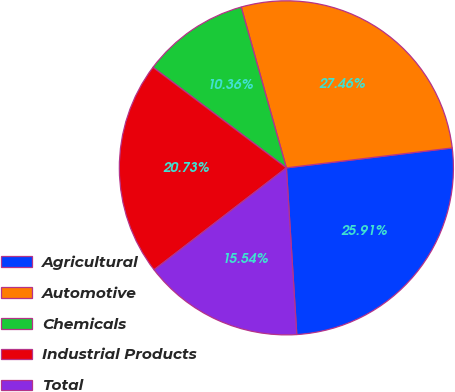<chart> <loc_0><loc_0><loc_500><loc_500><pie_chart><fcel>Agricultural<fcel>Automotive<fcel>Chemicals<fcel>Industrial Products<fcel>Total<nl><fcel>25.91%<fcel>27.46%<fcel>10.36%<fcel>20.73%<fcel>15.54%<nl></chart> 